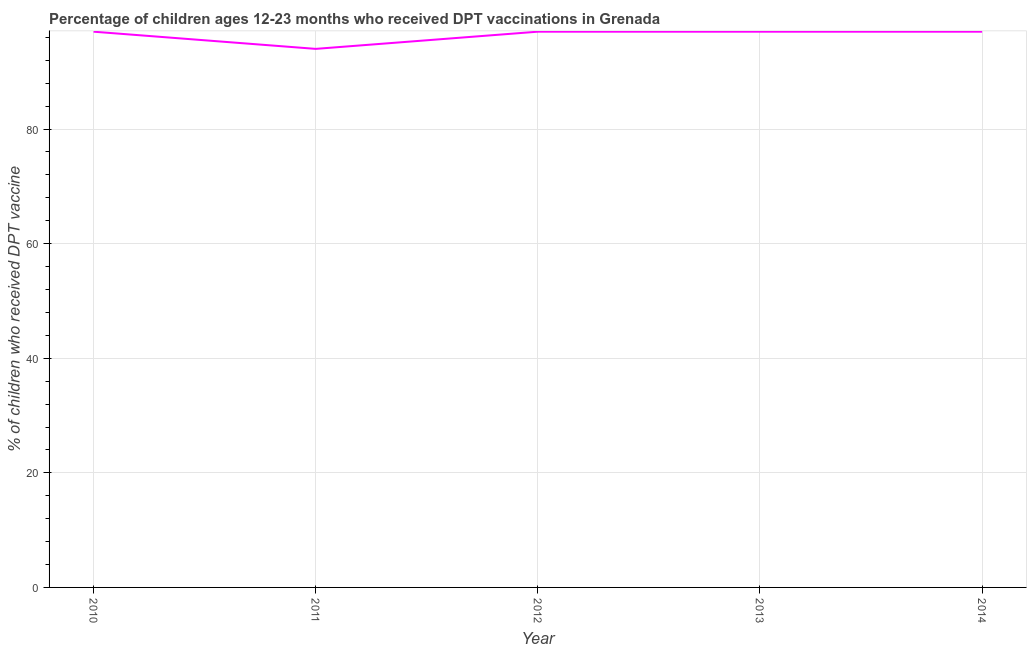What is the percentage of children who received dpt vaccine in 2011?
Give a very brief answer. 94. Across all years, what is the maximum percentage of children who received dpt vaccine?
Offer a very short reply. 97. Across all years, what is the minimum percentage of children who received dpt vaccine?
Your answer should be very brief. 94. In which year was the percentage of children who received dpt vaccine maximum?
Give a very brief answer. 2010. What is the sum of the percentage of children who received dpt vaccine?
Make the answer very short. 482. What is the average percentage of children who received dpt vaccine per year?
Keep it short and to the point. 96.4. What is the median percentage of children who received dpt vaccine?
Provide a short and direct response. 97. In how many years, is the percentage of children who received dpt vaccine greater than 72 %?
Ensure brevity in your answer.  5. What is the ratio of the percentage of children who received dpt vaccine in 2010 to that in 2013?
Make the answer very short. 1. Is the percentage of children who received dpt vaccine in 2010 less than that in 2013?
Provide a short and direct response. No. Is the difference between the percentage of children who received dpt vaccine in 2013 and 2014 greater than the difference between any two years?
Keep it short and to the point. No. What is the difference between the highest and the second highest percentage of children who received dpt vaccine?
Ensure brevity in your answer.  0. Is the sum of the percentage of children who received dpt vaccine in 2010 and 2013 greater than the maximum percentage of children who received dpt vaccine across all years?
Provide a short and direct response. Yes. What is the difference between the highest and the lowest percentage of children who received dpt vaccine?
Make the answer very short. 3. Does the percentage of children who received dpt vaccine monotonically increase over the years?
Your response must be concise. No. How many lines are there?
Keep it short and to the point. 1. Are the values on the major ticks of Y-axis written in scientific E-notation?
Offer a terse response. No. Does the graph contain any zero values?
Offer a terse response. No. Does the graph contain grids?
Your answer should be very brief. Yes. What is the title of the graph?
Your answer should be very brief. Percentage of children ages 12-23 months who received DPT vaccinations in Grenada. What is the label or title of the X-axis?
Make the answer very short. Year. What is the label or title of the Y-axis?
Provide a short and direct response. % of children who received DPT vaccine. What is the % of children who received DPT vaccine of 2010?
Make the answer very short. 97. What is the % of children who received DPT vaccine in 2011?
Your answer should be compact. 94. What is the % of children who received DPT vaccine of 2012?
Provide a short and direct response. 97. What is the % of children who received DPT vaccine in 2013?
Keep it short and to the point. 97. What is the % of children who received DPT vaccine in 2014?
Keep it short and to the point. 97. What is the difference between the % of children who received DPT vaccine in 2010 and 2011?
Ensure brevity in your answer.  3. What is the difference between the % of children who received DPT vaccine in 2010 and 2012?
Give a very brief answer. 0. What is the difference between the % of children who received DPT vaccine in 2010 and 2013?
Ensure brevity in your answer.  0. What is the difference between the % of children who received DPT vaccine in 2010 and 2014?
Ensure brevity in your answer.  0. What is the difference between the % of children who received DPT vaccine in 2011 and 2012?
Give a very brief answer. -3. What is the difference between the % of children who received DPT vaccine in 2011 and 2013?
Your response must be concise. -3. What is the difference between the % of children who received DPT vaccine in 2012 and 2013?
Provide a succinct answer. 0. What is the difference between the % of children who received DPT vaccine in 2012 and 2014?
Your response must be concise. 0. What is the ratio of the % of children who received DPT vaccine in 2010 to that in 2011?
Keep it short and to the point. 1.03. What is the ratio of the % of children who received DPT vaccine in 2010 to that in 2012?
Provide a short and direct response. 1. What is the ratio of the % of children who received DPT vaccine in 2010 to that in 2014?
Offer a very short reply. 1. What is the ratio of the % of children who received DPT vaccine in 2011 to that in 2014?
Give a very brief answer. 0.97. What is the ratio of the % of children who received DPT vaccine in 2012 to that in 2014?
Make the answer very short. 1. 